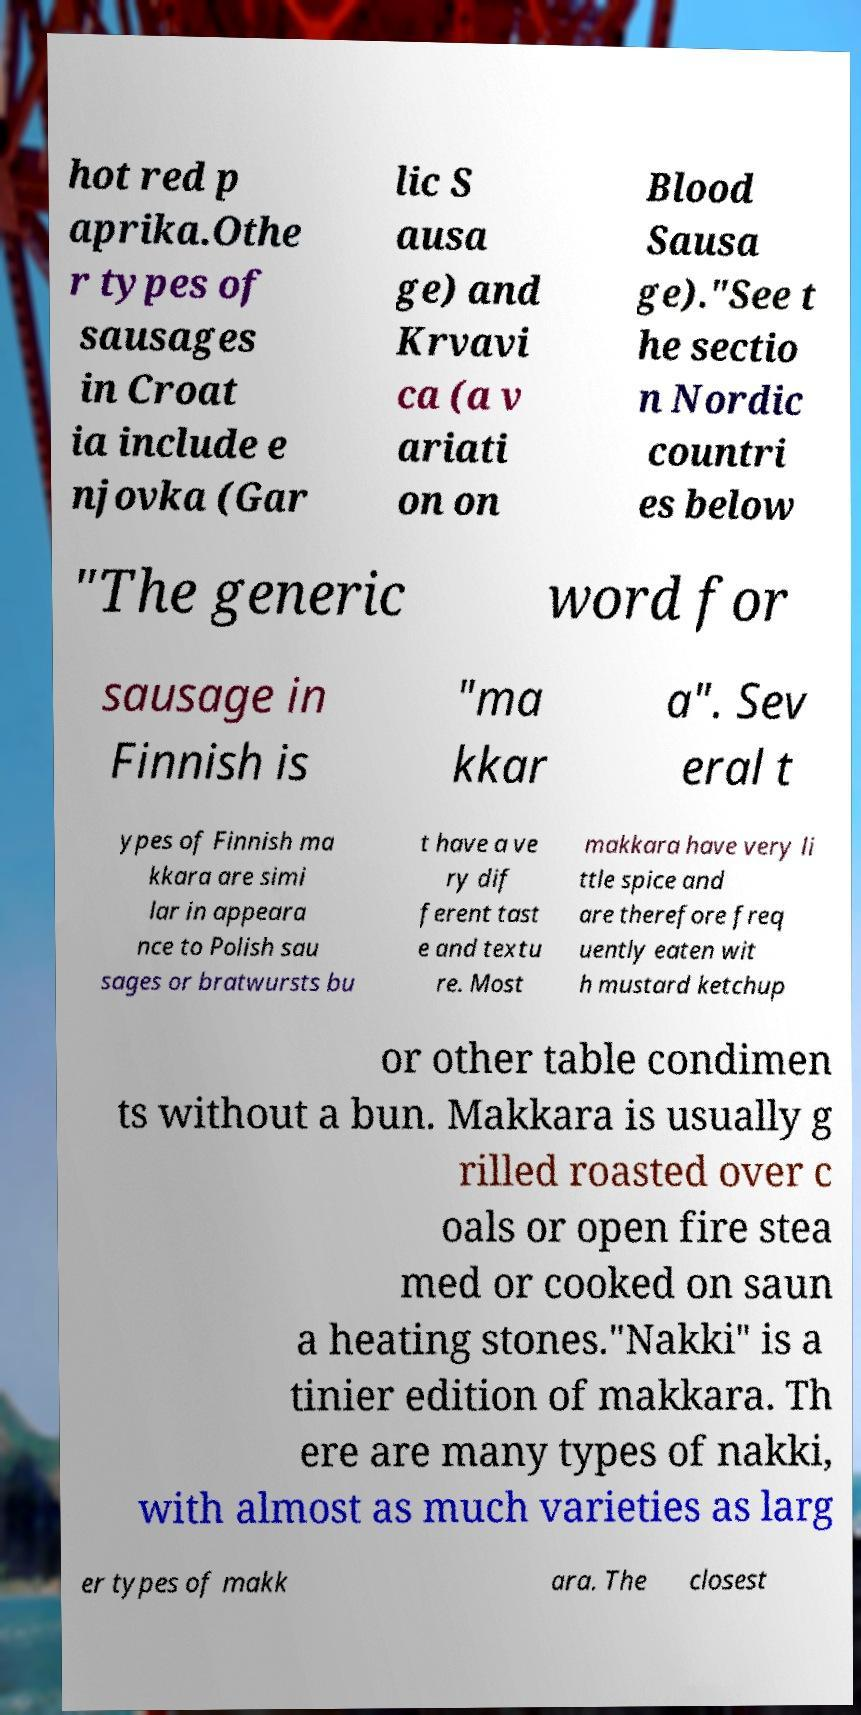Could you assist in decoding the text presented in this image and type it out clearly? hot red p aprika.Othe r types of sausages in Croat ia include e njovka (Gar lic S ausa ge) and Krvavi ca (a v ariati on on Blood Sausa ge)."See t he sectio n Nordic countri es below "The generic word for sausage in Finnish is "ma kkar a". Sev eral t ypes of Finnish ma kkara are simi lar in appeara nce to Polish sau sages or bratwursts bu t have a ve ry dif ferent tast e and textu re. Most makkara have very li ttle spice and are therefore freq uently eaten wit h mustard ketchup or other table condimen ts without a bun. Makkara is usually g rilled roasted over c oals or open fire stea med or cooked on saun a heating stones."Nakki" is a tinier edition of makkara. Th ere are many types of nakki, with almost as much varieties as larg er types of makk ara. The closest 